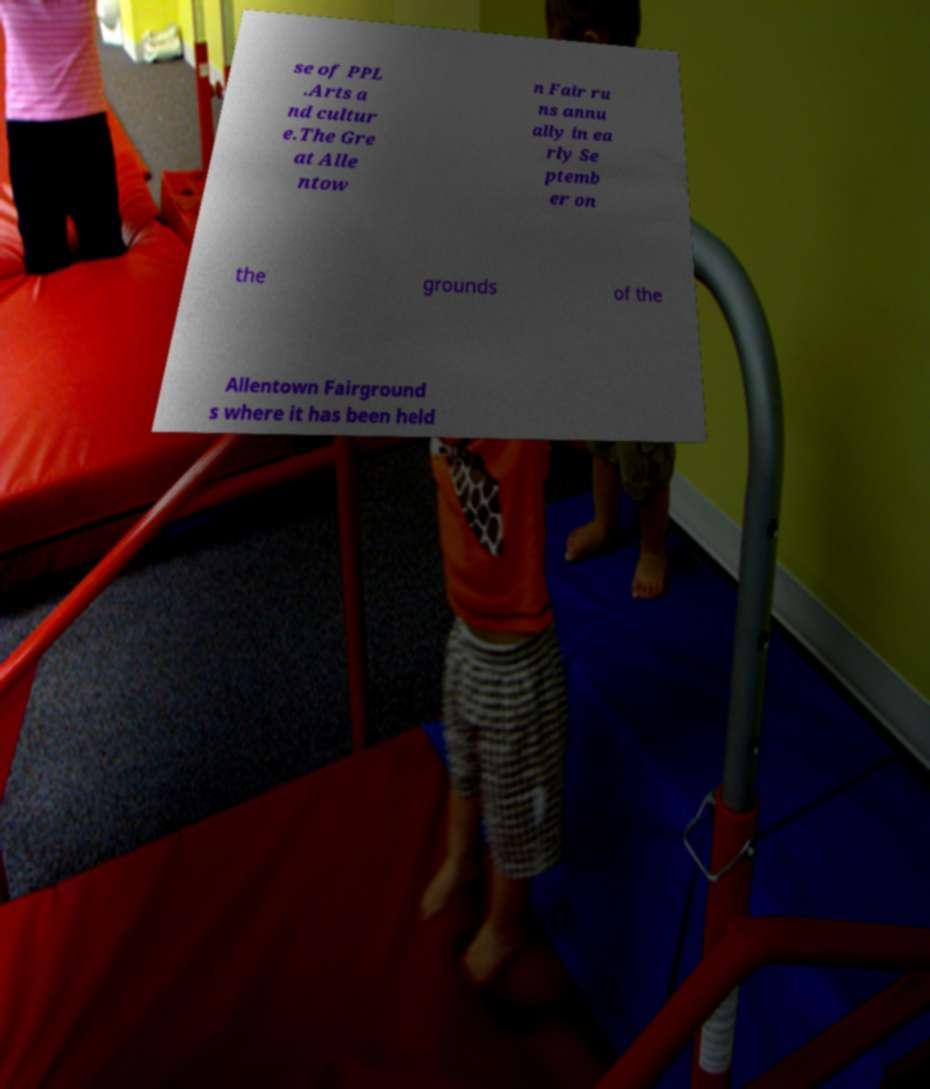For documentation purposes, I need the text within this image transcribed. Could you provide that? se of PPL .Arts a nd cultur e.The Gre at Alle ntow n Fair ru ns annu ally in ea rly Se ptemb er on the grounds of the Allentown Fairground s where it has been held 